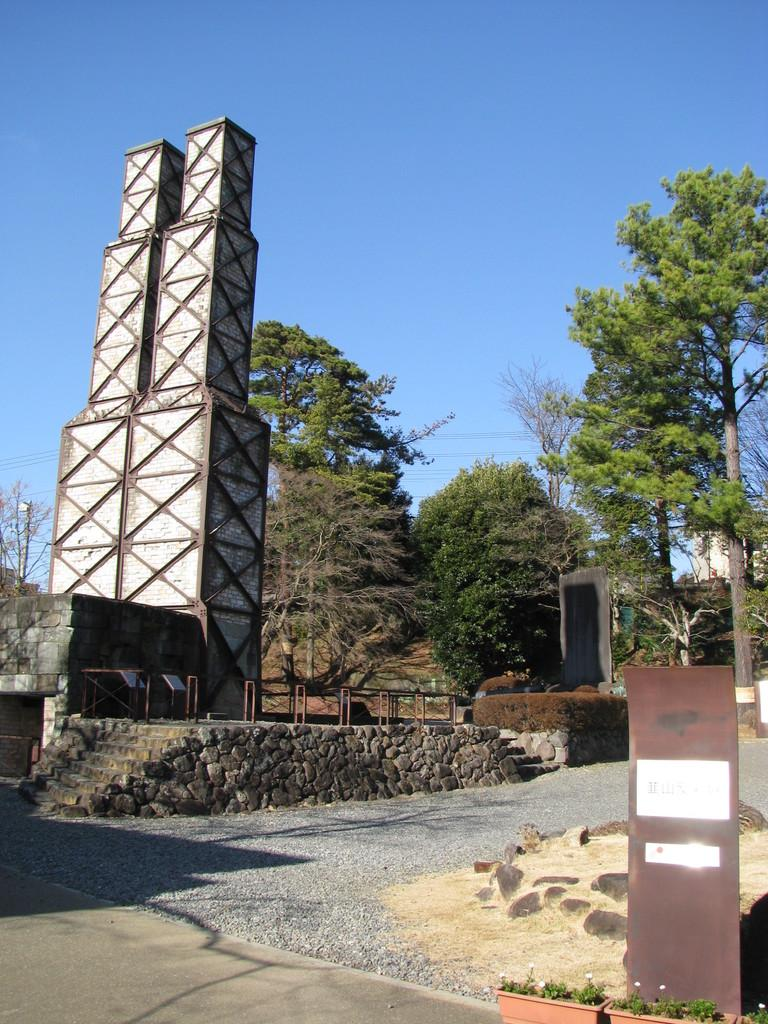What type of structure is present in the image? There is a building in the image. What is the color of the building? The building is gray in color. What can be seen in the background of the image? There are trees in the background of the image. What is the color of the trees? The trees are green in color. What is visible above the building and trees? The sky is visible in the image. What is the color of the sky? The sky is blue in color. What flavor of snow can be seen on the shelf in the image? There is no shelf or snow present in the image. 